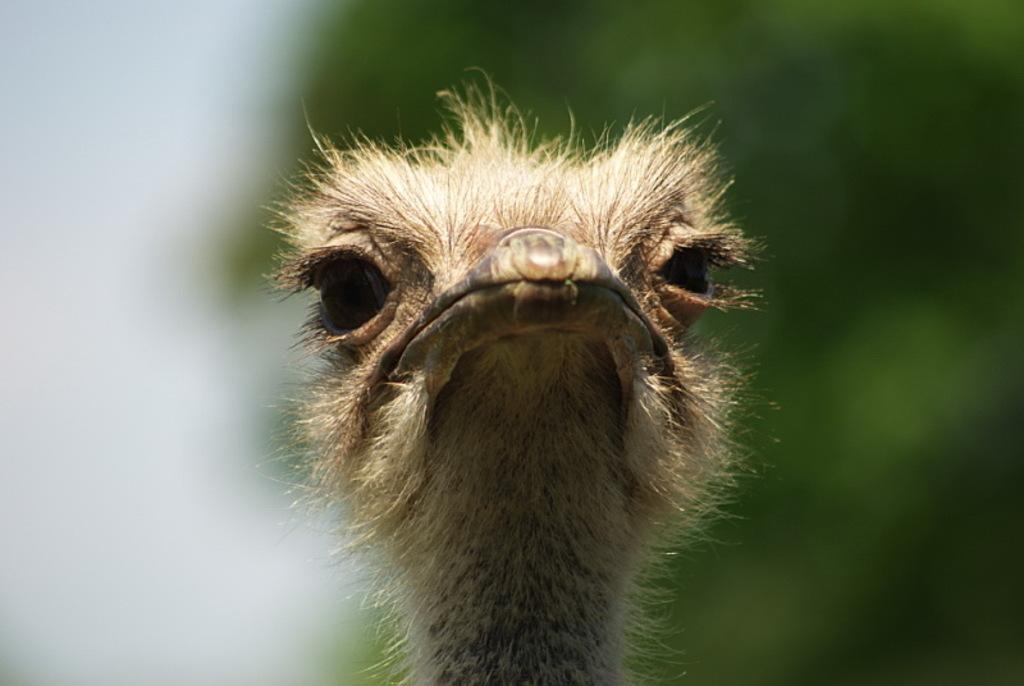In one or two sentences, can you explain what this image depicts? In this picture we can see the head of a bird and in the background it is blurry. 